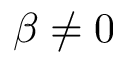Convert formula to latex. <formula><loc_0><loc_0><loc_500><loc_500>\beta \neq 0</formula> 